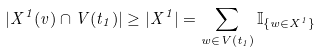Convert formula to latex. <formula><loc_0><loc_0><loc_500><loc_500>| X ^ { 1 } ( v ) \cap V ( t _ { 1 } ) | \geq | X ^ { 1 } | = \sum _ { w \in V ( t _ { 1 } ) } { \mathbb { I } } _ { \{ w \in X ^ { 1 } \} }</formula> 